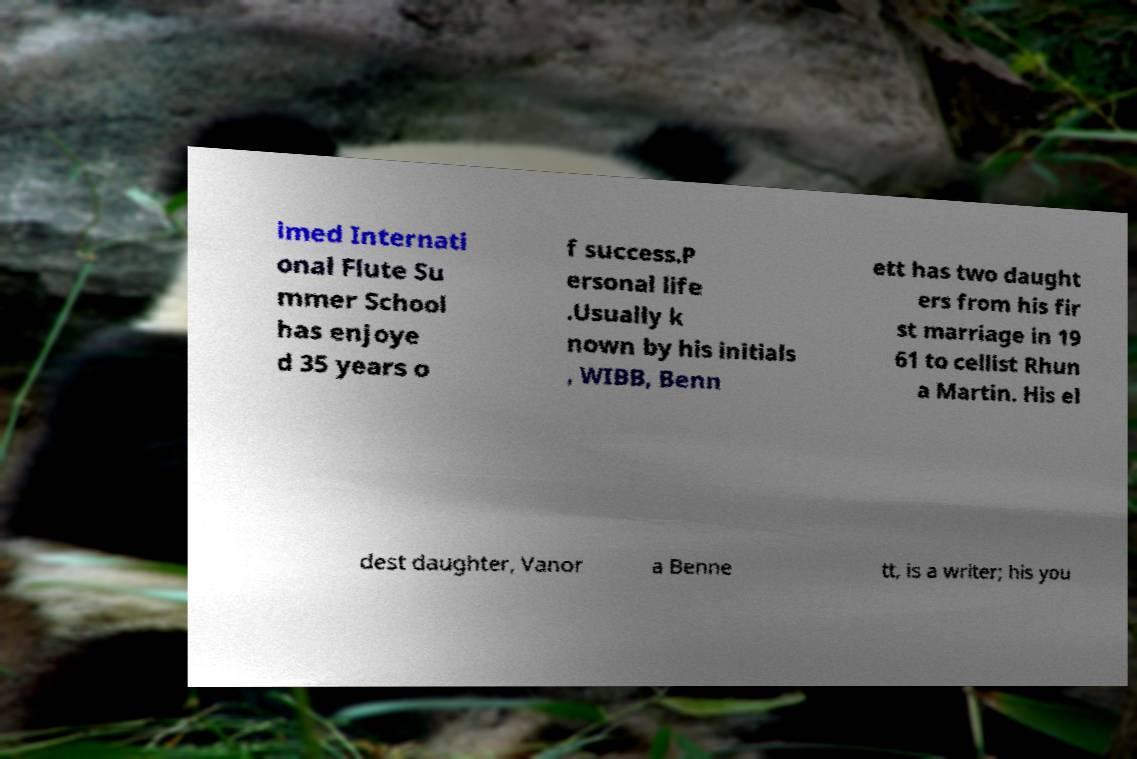What messages or text are displayed in this image? I need them in a readable, typed format. imed Internati onal Flute Su mmer School has enjoye d 35 years o f success.P ersonal life .Usually k nown by his initials , WIBB, Benn ett has two daught ers from his fir st marriage in 19 61 to cellist Rhun a Martin. His el dest daughter, Vanor a Benne tt, is a writer; his you 